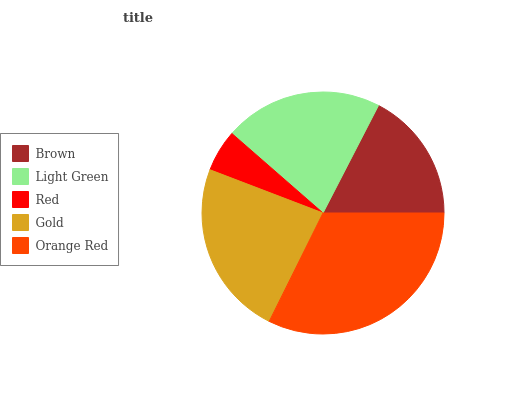Is Red the minimum?
Answer yes or no. Yes. Is Orange Red the maximum?
Answer yes or no. Yes. Is Light Green the minimum?
Answer yes or no. No. Is Light Green the maximum?
Answer yes or no. No. Is Light Green greater than Brown?
Answer yes or no. Yes. Is Brown less than Light Green?
Answer yes or no. Yes. Is Brown greater than Light Green?
Answer yes or no. No. Is Light Green less than Brown?
Answer yes or no. No. Is Light Green the high median?
Answer yes or no. Yes. Is Light Green the low median?
Answer yes or no. Yes. Is Brown the high median?
Answer yes or no. No. Is Orange Red the low median?
Answer yes or no. No. 